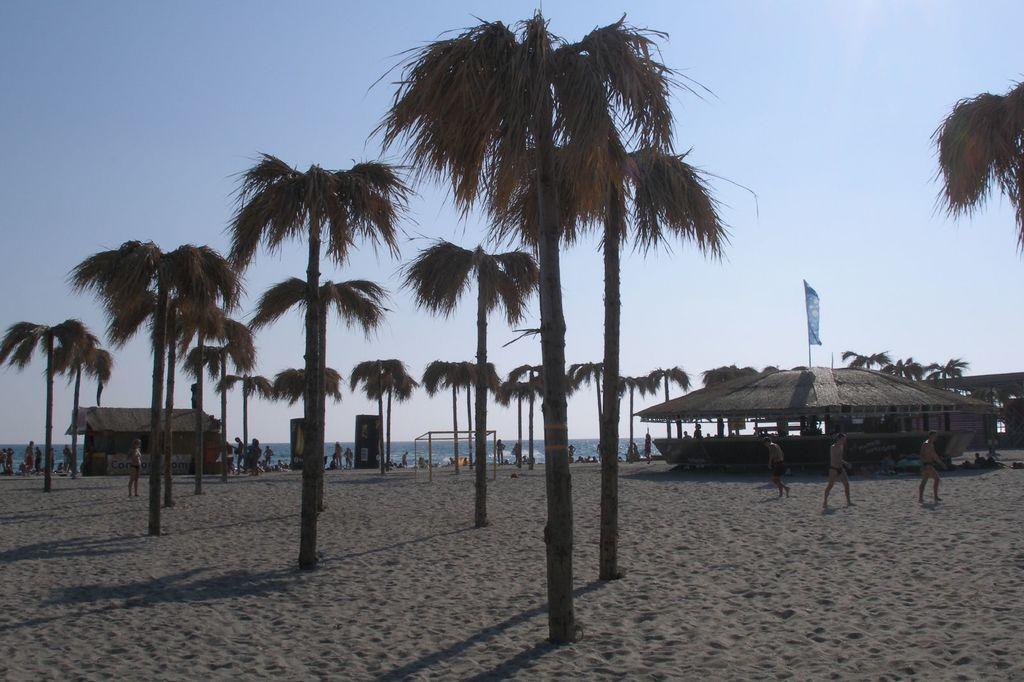How would you summarize this image in a sentence or two? This is a beach. Here I can few houses and trees on the ground. In the background there are few people and an ocean. At the top of the image I can see the sky. On the right side there are three persons walking on the ground. 